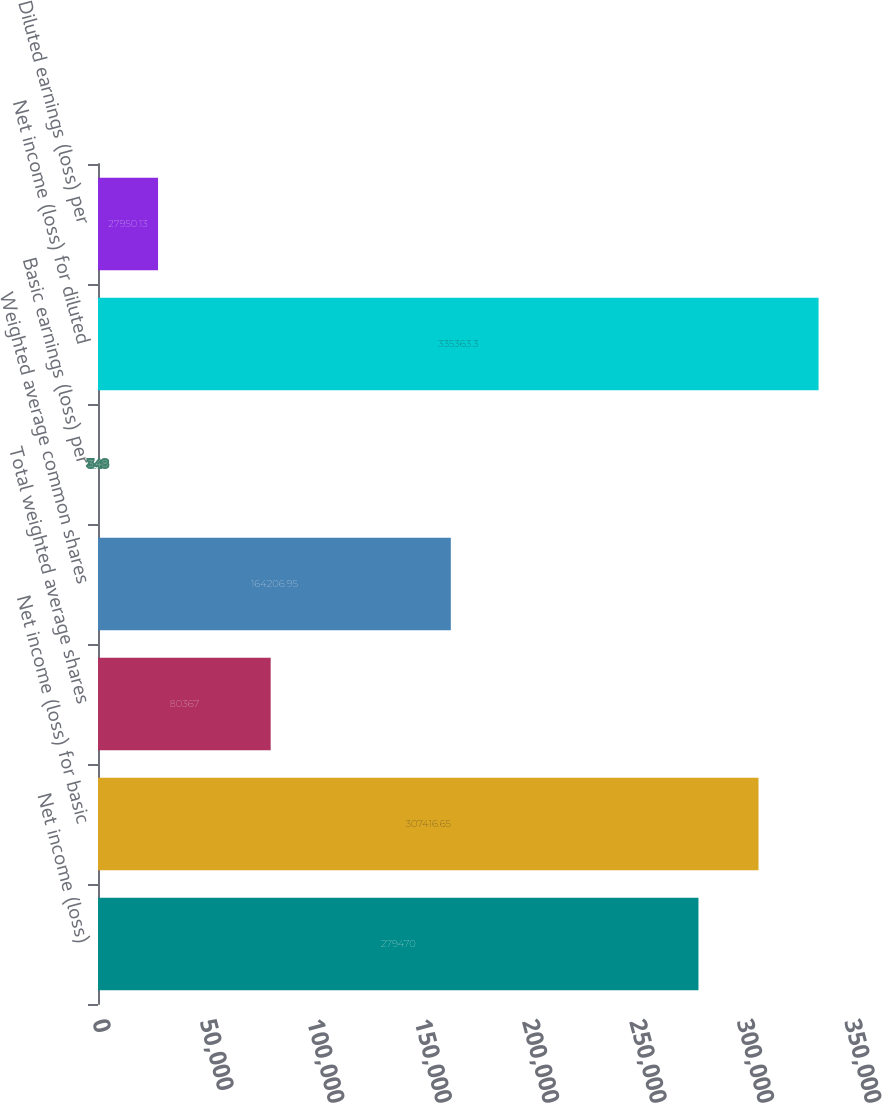<chart> <loc_0><loc_0><loc_500><loc_500><bar_chart><fcel>Net income (loss)<fcel>Net income (loss) for basic<fcel>Total weighted average shares<fcel>Weighted average common shares<fcel>Basic earnings (loss) per<fcel>Net income (loss) for diluted<fcel>Diluted earnings (loss) per<nl><fcel>279470<fcel>307417<fcel>80367<fcel>164207<fcel>3.48<fcel>335363<fcel>27950.1<nl></chart> 